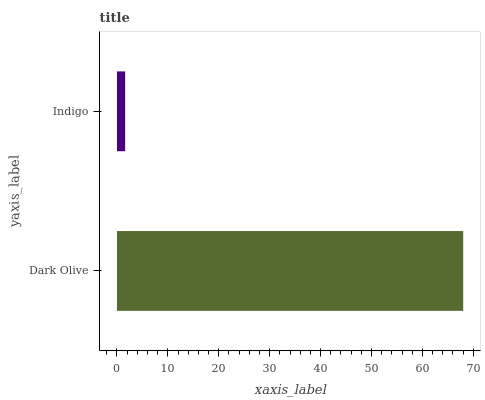Is Indigo the minimum?
Answer yes or no. Yes. Is Dark Olive the maximum?
Answer yes or no. Yes. Is Indigo the maximum?
Answer yes or no. No. Is Dark Olive greater than Indigo?
Answer yes or no. Yes. Is Indigo less than Dark Olive?
Answer yes or no. Yes. Is Indigo greater than Dark Olive?
Answer yes or no. No. Is Dark Olive less than Indigo?
Answer yes or no. No. Is Dark Olive the high median?
Answer yes or no. Yes. Is Indigo the low median?
Answer yes or no. Yes. Is Indigo the high median?
Answer yes or no. No. Is Dark Olive the low median?
Answer yes or no. No. 